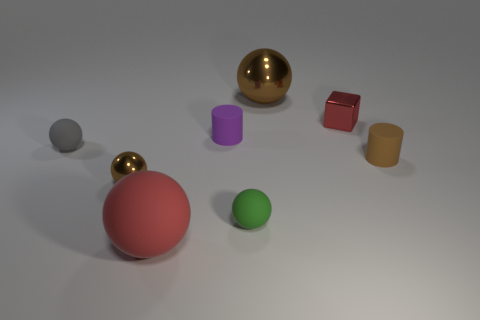Subtract all big balls. How many balls are left? 3 Add 1 small cyan rubber blocks. How many objects exist? 9 Subtract all purple cylinders. How many cylinders are left? 1 Subtract all cylinders. How many objects are left? 6 Add 6 gray rubber objects. How many gray rubber objects are left? 7 Add 8 yellow metallic balls. How many yellow metallic balls exist? 8 Subtract 0 cyan cylinders. How many objects are left? 8 Subtract 1 blocks. How many blocks are left? 0 Subtract all brown balls. Subtract all blue cylinders. How many balls are left? 3 Subtract all yellow cubes. How many cyan cylinders are left? 0 